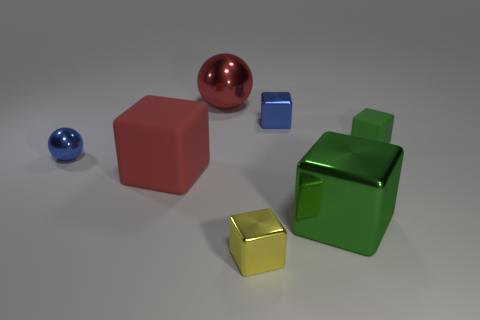Does the image suggest a specific kind of environment or context? The image seems to be neutral with no distinct setting, arranged in a studio-like environment with a plain background. It lacks context that would suggest a specific environment, intended more for object focus. Could you imagine a real-world application for the arrangement of these objects? The arrangement of these objects could be a reference setup for a still life drawing class, a color materials testing for a product photography shoot, or might be used in a puzzle or educational game to teach children about shapes and colors. 